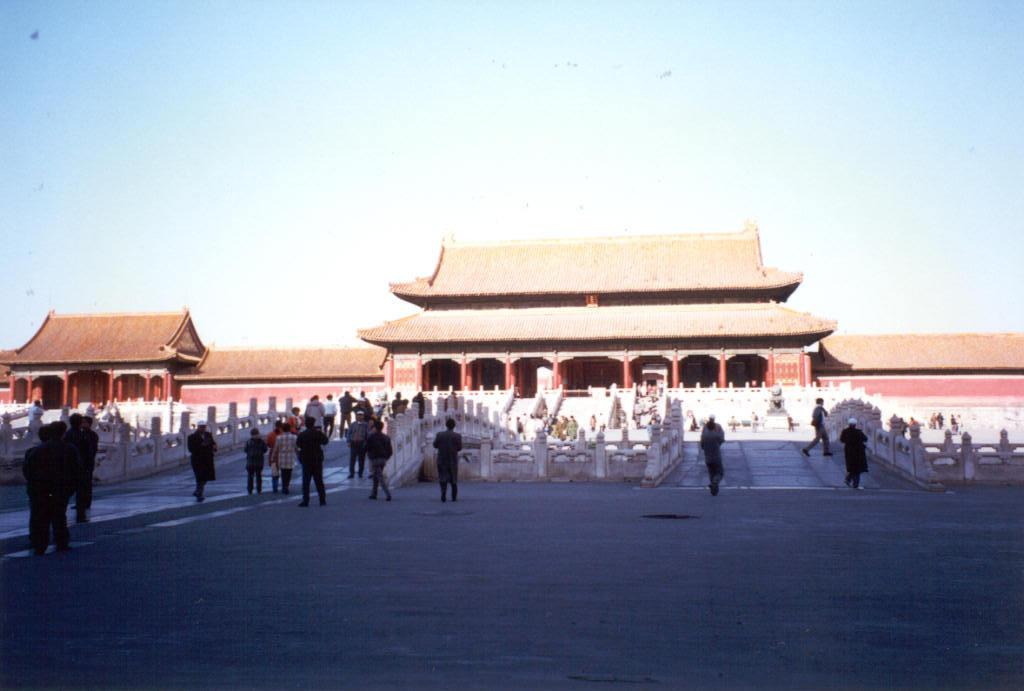What is the main structure in the middle of the image? There is a temple in the middle of the image. What is located in front of the temple? There is a bridge in front of the temple. What are the people in the image doing? People are walking on the bridge. What is visible at the top of the image? The sky is visible at the top of the image. What type of mint is growing near the temple in the image? There is no mint visible in the image; it features a temple, a bridge, and people walking on the bridge. Who is the owner of the temple in the image? The image does not provide information about the ownership of the temple. 